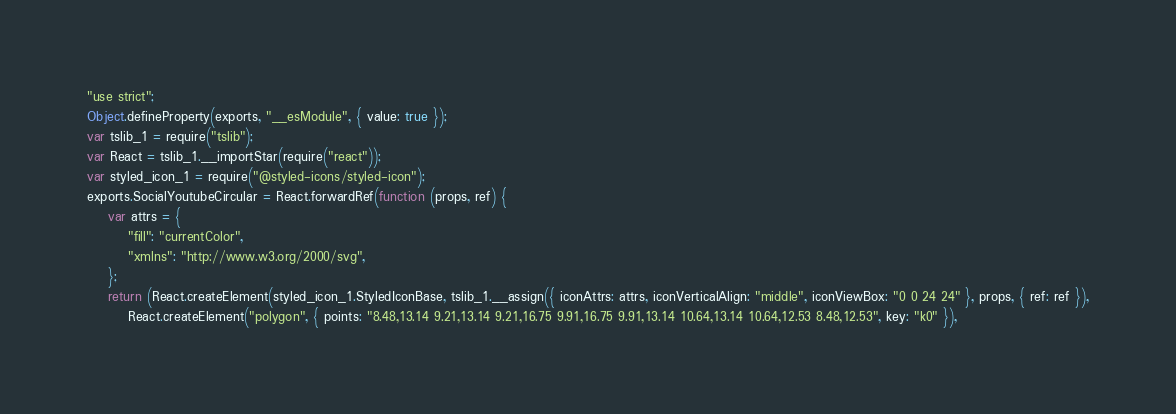Convert code to text. <code><loc_0><loc_0><loc_500><loc_500><_JavaScript_>"use strict";
Object.defineProperty(exports, "__esModule", { value: true });
var tslib_1 = require("tslib");
var React = tslib_1.__importStar(require("react"));
var styled_icon_1 = require("@styled-icons/styled-icon");
exports.SocialYoutubeCircular = React.forwardRef(function (props, ref) {
    var attrs = {
        "fill": "currentColor",
        "xmlns": "http://www.w3.org/2000/svg",
    };
    return (React.createElement(styled_icon_1.StyledIconBase, tslib_1.__assign({ iconAttrs: attrs, iconVerticalAlign: "middle", iconViewBox: "0 0 24 24" }, props, { ref: ref }),
        React.createElement("polygon", { points: "8.48,13.14 9.21,13.14 9.21,16.75 9.91,16.75 9.91,13.14 10.64,13.14 10.64,12.53 8.48,12.53", key: "k0" }),</code> 